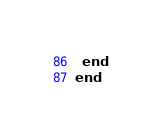Convert code to text. <code><loc_0><loc_0><loc_500><loc_500><_Ruby_>  end
end
</code> 